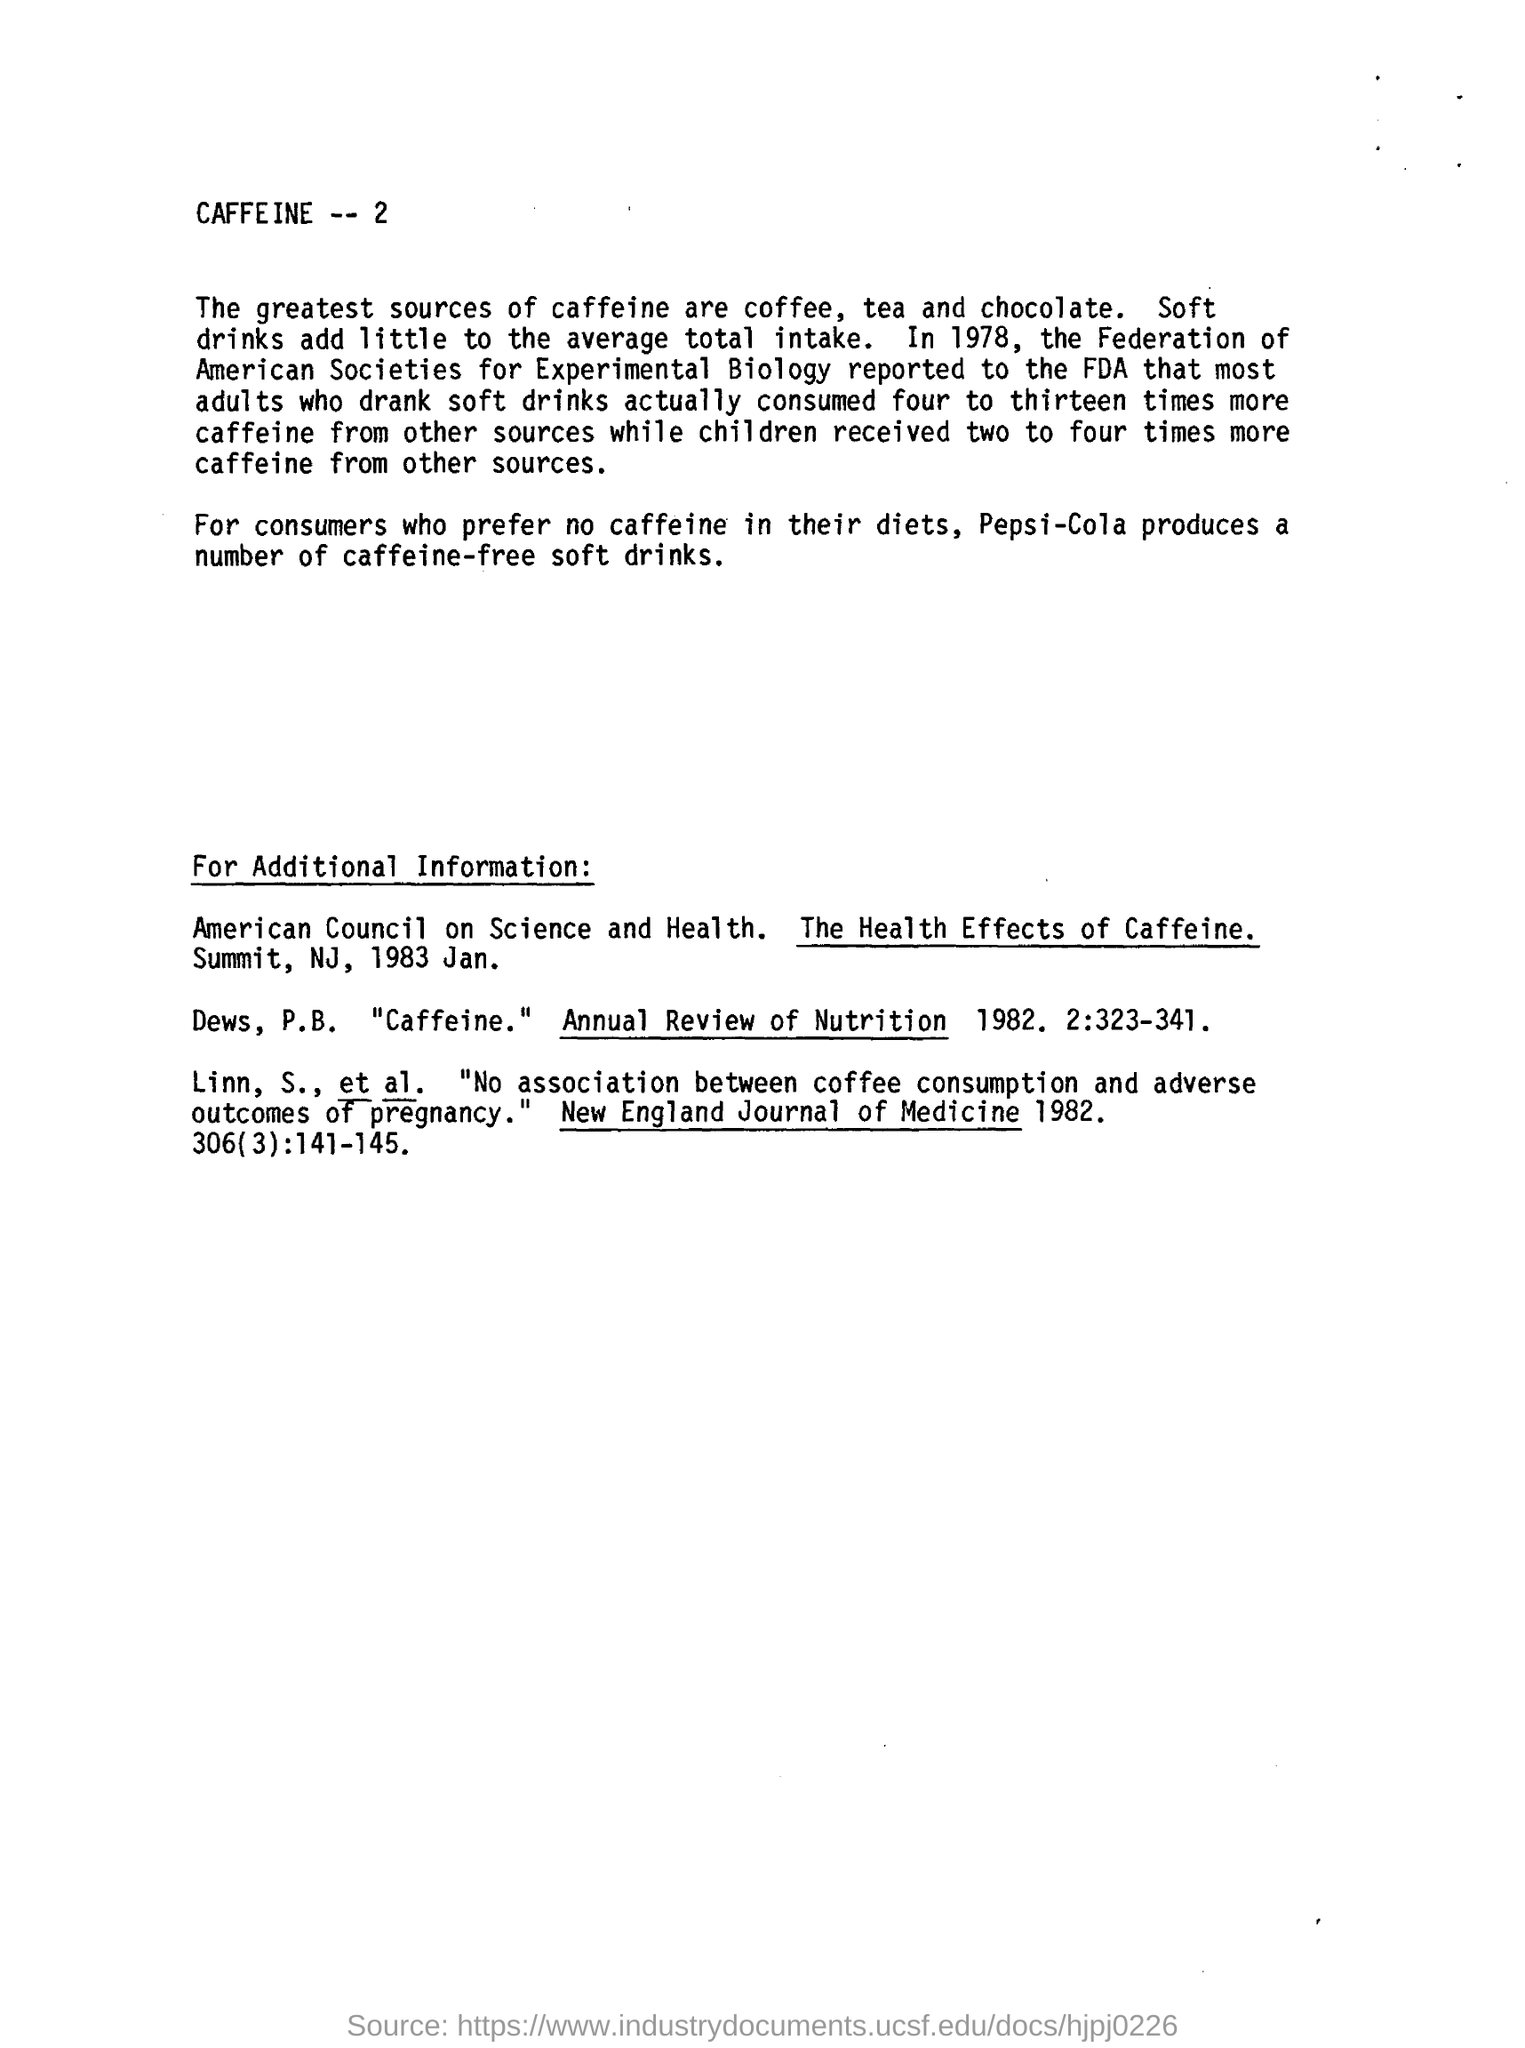what produces a number of caffeine free soft drink for those who prefer no caffeine in their diets? Several companies produce caffeine-free soft drinks to cater to those who prefer or need to avoid caffeine for dietary or health reasons. Some well-known brands that offer caffeine-free options include Pepsi-Cola with their Caffeine-Free Pepsi, Coca-Cola with Caffeine-Free Diet Coke, and Dr Pepper with their Caffeine-Free Dr Pepper variant. 